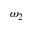<formula> <loc_0><loc_0><loc_500><loc_500>\omega _ { 2 }</formula> 